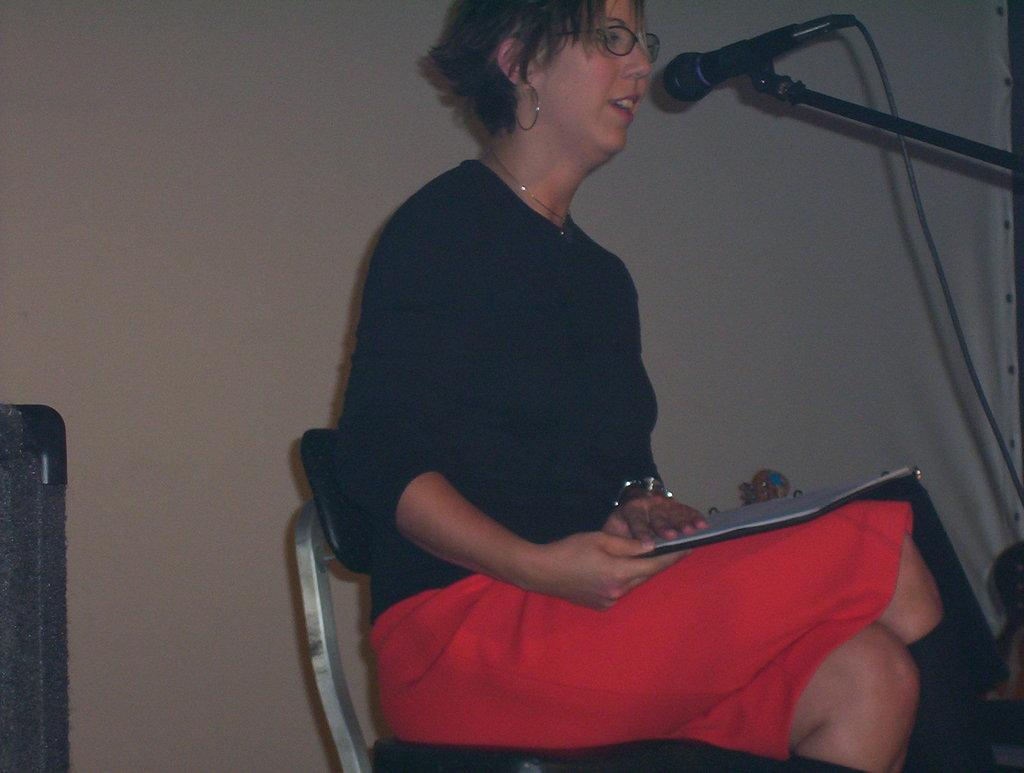Who is present in the image? There is a woman in the image. What is the woman doing in the image? The woman is sitting on a chair and holding a book. What object related to sound can be seen in the image? There is a microphone with a microphone stand in the image. Can you describe the background of the image? There is a wall in the background of the image. How many objects can be seen in the image? There are objects in the image, but the exact number is not specified. What type of verse is the woman reciting in the image? There is no indication in the image that the woman is reciting a verse, so it cannot be determined from the picture. 